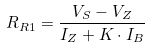Convert formula to latex. <formula><loc_0><loc_0><loc_500><loc_500>R _ { R 1 } = { \frac { V _ { S } - V _ { Z } } { I _ { Z } + K \cdot I _ { B } } }</formula> 